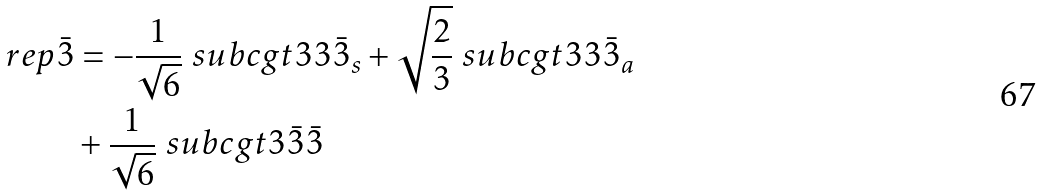Convert formula to latex. <formula><loc_0><loc_0><loc_500><loc_500>\ r e p { \bar { 3 } } & = - \frac { 1 } { \sqrt { 6 } } \ s u b c g t { 3 } { 3 } { \bar { 3 } _ { s } } + \sqrt { \frac { 2 } { 3 } } \ s u b c g t { 3 } { 3 } { \bar { 3 } _ { a } } \\ & + \frac { 1 } { \sqrt { 6 } } \ s u b c g t { 3 } { \bar { 3 } } { \bar { 3 } }</formula> 